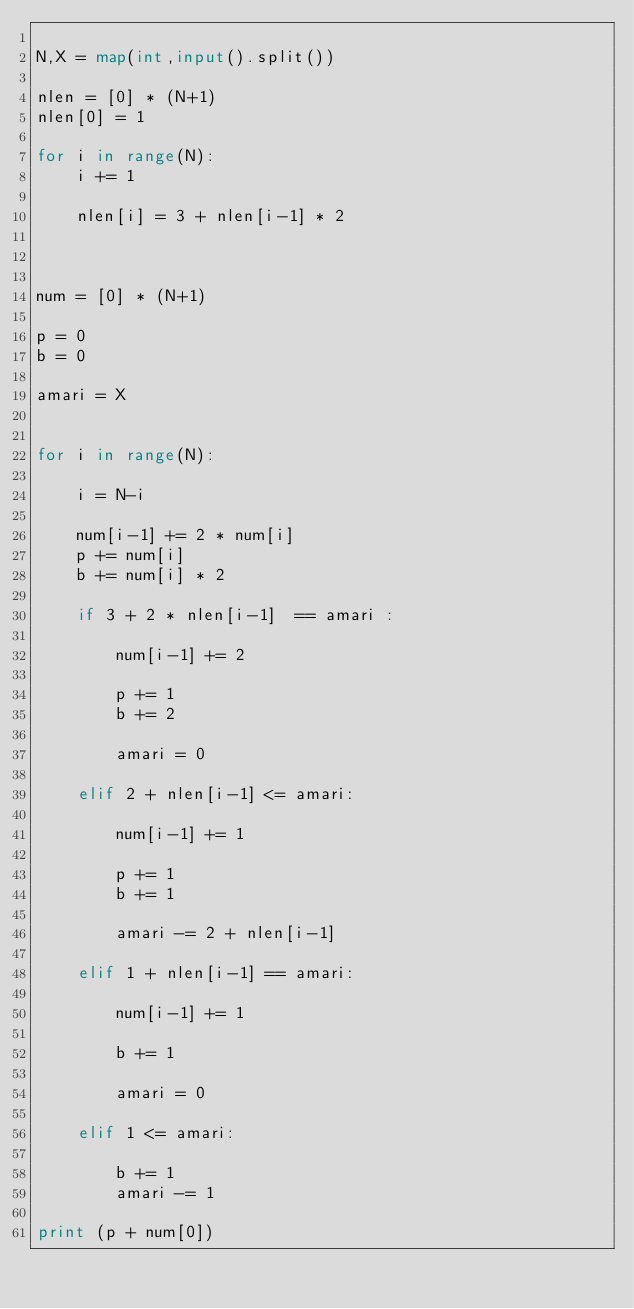<code> <loc_0><loc_0><loc_500><loc_500><_Python_>
N,X = map(int,input().split())

nlen = [0] * (N+1)
nlen[0] = 1

for i in range(N):
    i += 1

    nlen[i] = 3 + nlen[i-1] * 2

    
    
num = [0] * (N+1)

p = 0
b = 0

amari = X


for i in range(N):

    i = N-i

    num[i-1] += 2 * num[i]
    p += num[i]
    b += num[i] * 2

    if 3 + 2 * nlen[i-1]  == amari :

        num[i-1] += 2

        p += 1
        b += 2

        amari = 0

    elif 2 + nlen[i-1] <= amari:

        num[i-1] += 1

        p += 1
        b += 1

        amari -= 2 + nlen[i-1]

    elif 1 + nlen[i-1] == amari:

        num[i-1] += 1

        b += 1

        amari = 0

    elif 1 <= amari:

        b += 1
        amari -= 1

print (p + num[0])
</code> 